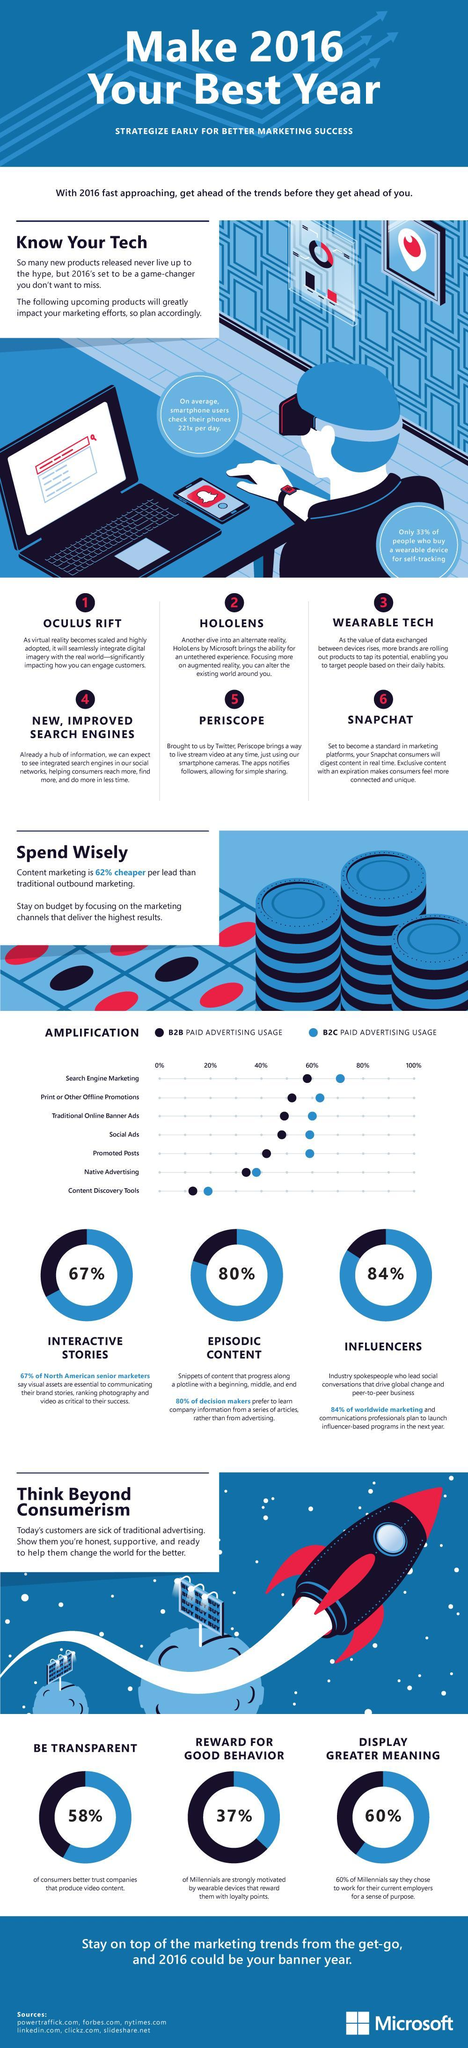how many millenials are motivated by wearable devices that reward them with loyalty points
Answer the question with a short phrase. 37% in which type of paid advertising is usage by both B2B and B2C nearly the same Native Advertising What can be used to livestream videos Periscope What provides exclusive content with an expiration Snapchat what are the 3 key traits that consumers expect be transparent, reward for good behaviour, display greater meaning What is the B2C paid advertising usage of Search engine marketing 70% what can help target people based on their daily habits wearable tech 